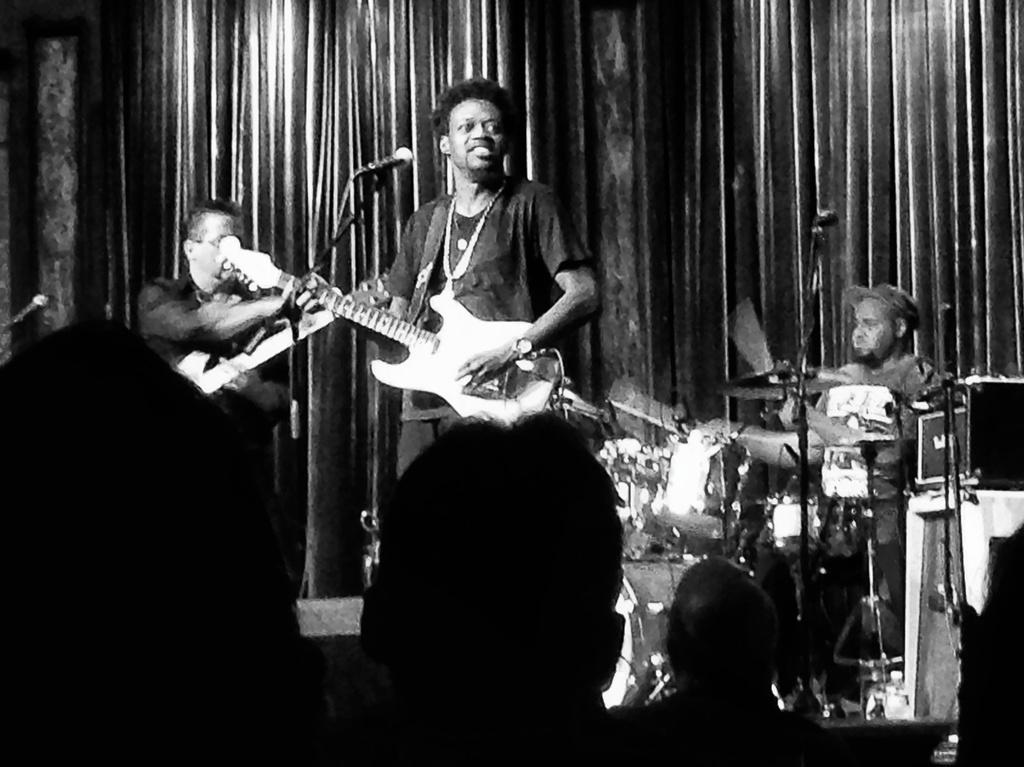Could you give a brief overview of what you see in this image? This picture shows a man standing and playing a guitar,a man seated and playing drums,we see a other man holding guitar in his hand and we see few audience watching them. 